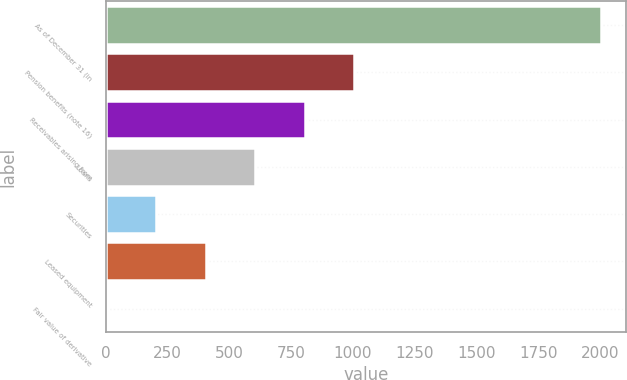Convert chart to OTSL. <chart><loc_0><loc_0><loc_500><loc_500><bar_chart><fcel>As of December 31 (in<fcel>Pension benefits (note 16)<fcel>Receivables arising from<fcel>Loans<fcel>Securities<fcel>Leased equipment<fcel>Fair value of derivative<nl><fcel>2005<fcel>1005.45<fcel>805.54<fcel>605.63<fcel>205.81<fcel>405.72<fcel>5.9<nl></chart> 